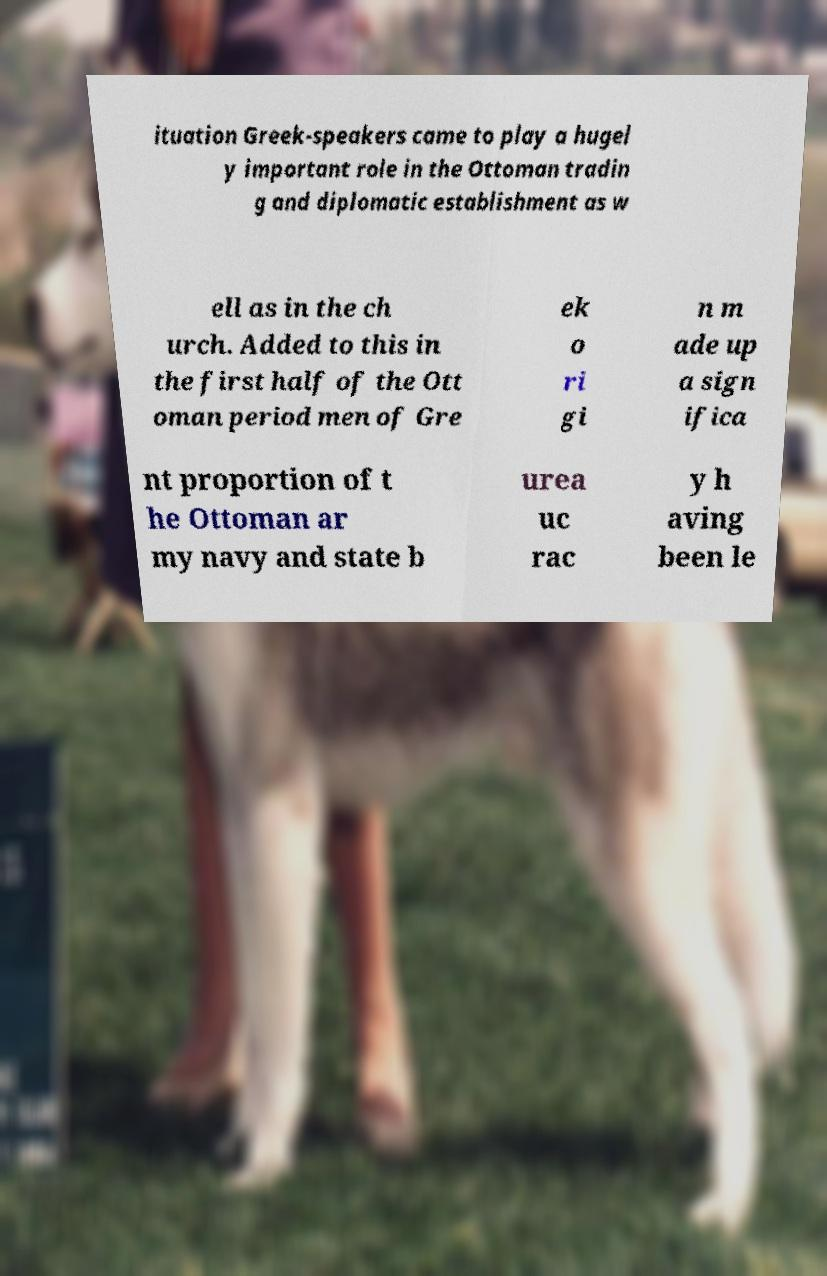Please read and relay the text visible in this image. What does it say? ituation Greek-speakers came to play a hugel y important role in the Ottoman tradin g and diplomatic establishment as w ell as in the ch urch. Added to this in the first half of the Ott oman period men of Gre ek o ri gi n m ade up a sign ifica nt proportion of t he Ottoman ar my navy and state b urea uc rac y h aving been le 